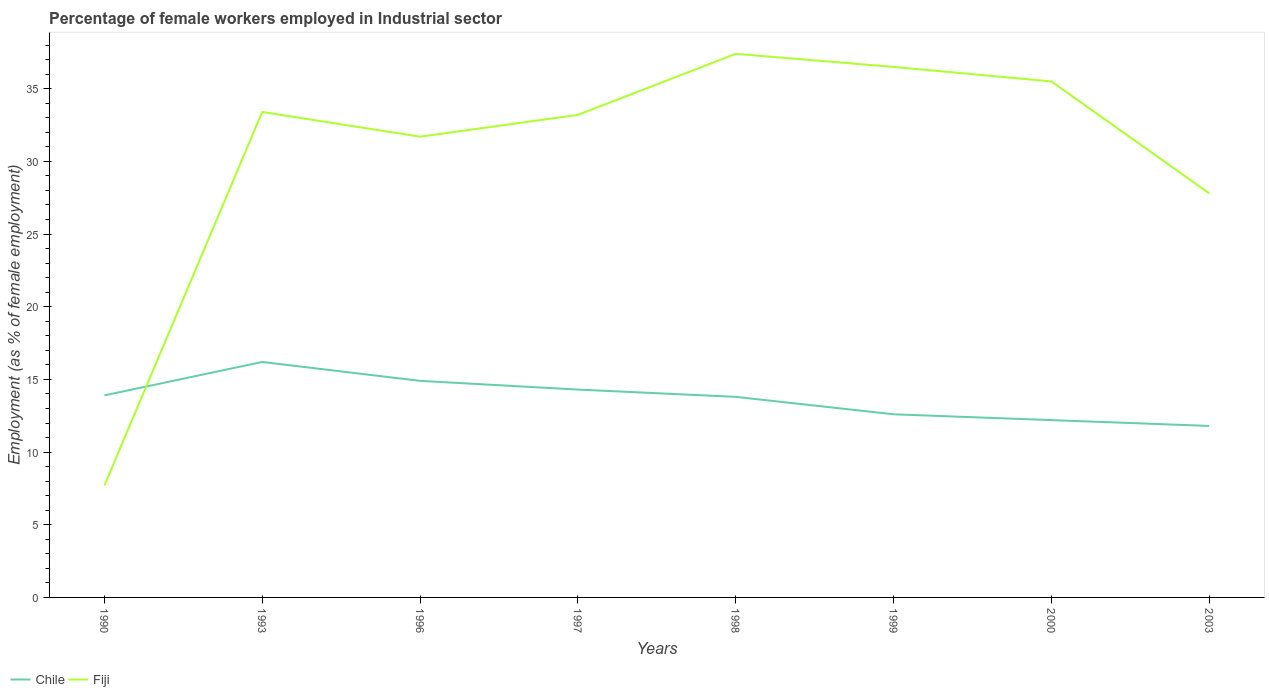How many different coloured lines are there?
Your answer should be compact. 2. Does the line corresponding to Fiji intersect with the line corresponding to Chile?
Your answer should be very brief. Yes. Is the number of lines equal to the number of legend labels?
Your answer should be very brief. Yes. Across all years, what is the maximum percentage of females employed in Industrial sector in Chile?
Provide a short and direct response. 11.8. What is the difference between the highest and the second highest percentage of females employed in Industrial sector in Fiji?
Give a very brief answer. 29.7. How many lines are there?
Offer a terse response. 2. Are the values on the major ticks of Y-axis written in scientific E-notation?
Keep it short and to the point. No. Where does the legend appear in the graph?
Your answer should be very brief. Bottom left. How many legend labels are there?
Offer a terse response. 2. How are the legend labels stacked?
Provide a short and direct response. Horizontal. What is the title of the graph?
Your answer should be very brief. Percentage of female workers employed in Industrial sector. What is the label or title of the X-axis?
Provide a short and direct response. Years. What is the label or title of the Y-axis?
Keep it short and to the point. Employment (as % of female employment). What is the Employment (as % of female employment) in Chile in 1990?
Provide a short and direct response. 13.9. What is the Employment (as % of female employment) in Fiji in 1990?
Give a very brief answer. 7.7. What is the Employment (as % of female employment) of Chile in 1993?
Keep it short and to the point. 16.2. What is the Employment (as % of female employment) in Fiji in 1993?
Make the answer very short. 33.4. What is the Employment (as % of female employment) of Chile in 1996?
Offer a very short reply. 14.9. What is the Employment (as % of female employment) of Fiji in 1996?
Your answer should be compact. 31.7. What is the Employment (as % of female employment) in Chile in 1997?
Your answer should be very brief. 14.3. What is the Employment (as % of female employment) of Fiji in 1997?
Ensure brevity in your answer.  33.2. What is the Employment (as % of female employment) in Chile in 1998?
Your answer should be very brief. 13.8. What is the Employment (as % of female employment) of Fiji in 1998?
Provide a succinct answer. 37.4. What is the Employment (as % of female employment) in Chile in 1999?
Your answer should be very brief. 12.6. What is the Employment (as % of female employment) of Fiji in 1999?
Provide a short and direct response. 36.5. What is the Employment (as % of female employment) in Chile in 2000?
Make the answer very short. 12.2. What is the Employment (as % of female employment) of Fiji in 2000?
Provide a short and direct response. 35.5. What is the Employment (as % of female employment) in Chile in 2003?
Make the answer very short. 11.8. What is the Employment (as % of female employment) in Fiji in 2003?
Offer a very short reply. 27.8. Across all years, what is the maximum Employment (as % of female employment) in Chile?
Your answer should be compact. 16.2. Across all years, what is the maximum Employment (as % of female employment) of Fiji?
Provide a succinct answer. 37.4. Across all years, what is the minimum Employment (as % of female employment) in Chile?
Provide a succinct answer. 11.8. Across all years, what is the minimum Employment (as % of female employment) in Fiji?
Your response must be concise. 7.7. What is the total Employment (as % of female employment) in Chile in the graph?
Make the answer very short. 109.7. What is the total Employment (as % of female employment) in Fiji in the graph?
Your answer should be compact. 243.2. What is the difference between the Employment (as % of female employment) of Fiji in 1990 and that in 1993?
Provide a succinct answer. -25.7. What is the difference between the Employment (as % of female employment) in Chile in 1990 and that in 1996?
Offer a very short reply. -1. What is the difference between the Employment (as % of female employment) of Chile in 1990 and that in 1997?
Provide a short and direct response. -0.4. What is the difference between the Employment (as % of female employment) in Fiji in 1990 and that in 1997?
Offer a very short reply. -25.5. What is the difference between the Employment (as % of female employment) in Fiji in 1990 and that in 1998?
Give a very brief answer. -29.7. What is the difference between the Employment (as % of female employment) of Fiji in 1990 and that in 1999?
Keep it short and to the point. -28.8. What is the difference between the Employment (as % of female employment) in Fiji in 1990 and that in 2000?
Offer a terse response. -27.8. What is the difference between the Employment (as % of female employment) in Chile in 1990 and that in 2003?
Provide a succinct answer. 2.1. What is the difference between the Employment (as % of female employment) in Fiji in 1990 and that in 2003?
Keep it short and to the point. -20.1. What is the difference between the Employment (as % of female employment) of Chile in 1993 and that in 1996?
Your response must be concise. 1.3. What is the difference between the Employment (as % of female employment) of Fiji in 1993 and that in 1996?
Your response must be concise. 1.7. What is the difference between the Employment (as % of female employment) in Chile in 1993 and that in 1998?
Ensure brevity in your answer.  2.4. What is the difference between the Employment (as % of female employment) of Chile in 1993 and that in 1999?
Offer a very short reply. 3.6. What is the difference between the Employment (as % of female employment) of Fiji in 1993 and that in 2000?
Provide a short and direct response. -2.1. What is the difference between the Employment (as % of female employment) of Chile in 1996 and that in 1999?
Offer a terse response. 2.3. What is the difference between the Employment (as % of female employment) of Fiji in 1996 and that in 1999?
Ensure brevity in your answer.  -4.8. What is the difference between the Employment (as % of female employment) of Chile in 1996 and that in 2000?
Provide a succinct answer. 2.7. What is the difference between the Employment (as % of female employment) of Fiji in 1996 and that in 2000?
Your answer should be very brief. -3.8. What is the difference between the Employment (as % of female employment) of Fiji in 1996 and that in 2003?
Your answer should be very brief. 3.9. What is the difference between the Employment (as % of female employment) in Fiji in 1997 and that in 1998?
Your answer should be compact. -4.2. What is the difference between the Employment (as % of female employment) of Chile in 1997 and that in 1999?
Provide a short and direct response. 1.7. What is the difference between the Employment (as % of female employment) in Fiji in 1997 and that in 1999?
Your answer should be compact. -3.3. What is the difference between the Employment (as % of female employment) in Chile in 1997 and that in 2000?
Offer a very short reply. 2.1. What is the difference between the Employment (as % of female employment) in Chile in 1997 and that in 2003?
Your answer should be very brief. 2.5. What is the difference between the Employment (as % of female employment) of Fiji in 1997 and that in 2003?
Provide a short and direct response. 5.4. What is the difference between the Employment (as % of female employment) in Fiji in 1998 and that in 2000?
Provide a succinct answer. 1.9. What is the difference between the Employment (as % of female employment) of Chile in 2000 and that in 2003?
Make the answer very short. 0.4. What is the difference between the Employment (as % of female employment) in Chile in 1990 and the Employment (as % of female employment) in Fiji in 1993?
Provide a short and direct response. -19.5. What is the difference between the Employment (as % of female employment) in Chile in 1990 and the Employment (as % of female employment) in Fiji in 1996?
Give a very brief answer. -17.8. What is the difference between the Employment (as % of female employment) of Chile in 1990 and the Employment (as % of female employment) of Fiji in 1997?
Your response must be concise. -19.3. What is the difference between the Employment (as % of female employment) in Chile in 1990 and the Employment (as % of female employment) in Fiji in 1998?
Your answer should be compact. -23.5. What is the difference between the Employment (as % of female employment) in Chile in 1990 and the Employment (as % of female employment) in Fiji in 1999?
Make the answer very short. -22.6. What is the difference between the Employment (as % of female employment) in Chile in 1990 and the Employment (as % of female employment) in Fiji in 2000?
Offer a very short reply. -21.6. What is the difference between the Employment (as % of female employment) in Chile in 1990 and the Employment (as % of female employment) in Fiji in 2003?
Make the answer very short. -13.9. What is the difference between the Employment (as % of female employment) of Chile in 1993 and the Employment (as % of female employment) of Fiji in 1996?
Keep it short and to the point. -15.5. What is the difference between the Employment (as % of female employment) in Chile in 1993 and the Employment (as % of female employment) in Fiji in 1998?
Provide a succinct answer. -21.2. What is the difference between the Employment (as % of female employment) in Chile in 1993 and the Employment (as % of female employment) in Fiji in 1999?
Offer a terse response. -20.3. What is the difference between the Employment (as % of female employment) of Chile in 1993 and the Employment (as % of female employment) of Fiji in 2000?
Your response must be concise. -19.3. What is the difference between the Employment (as % of female employment) in Chile in 1996 and the Employment (as % of female employment) in Fiji in 1997?
Your answer should be very brief. -18.3. What is the difference between the Employment (as % of female employment) in Chile in 1996 and the Employment (as % of female employment) in Fiji in 1998?
Your response must be concise. -22.5. What is the difference between the Employment (as % of female employment) in Chile in 1996 and the Employment (as % of female employment) in Fiji in 1999?
Provide a short and direct response. -21.6. What is the difference between the Employment (as % of female employment) of Chile in 1996 and the Employment (as % of female employment) of Fiji in 2000?
Provide a succinct answer. -20.6. What is the difference between the Employment (as % of female employment) of Chile in 1997 and the Employment (as % of female employment) of Fiji in 1998?
Keep it short and to the point. -23.1. What is the difference between the Employment (as % of female employment) of Chile in 1997 and the Employment (as % of female employment) of Fiji in 1999?
Offer a very short reply. -22.2. What is the difference between the Employment (as % of female employment) in Chile in 1997 and the Employment (as % of female employment) in Fiji in 2000?
Offer a terse response. -21.2. What is the difference between the Employment (as % of female employment) in Chile in 1998 and the Employment (as % of female employment) in Fiji in 1999?
Provide a succinct answer. -22.7. What is the difference between the Employment (as % of female employment) of Chile in 1998 and the Employment (as % of female employment) of Fiji in 2000?
Keep it short and to the point. -21.7. What is the difference between the Employment (as % of female employment) in Chile in 1999 and the Employment (as % of female employment) in Fiji in 2000?
Offer a very short reply. -22.9. What is the difference between the Employment (as % of female employment) in Chile in 1999 and the Employment (as % of female employment) in Fiji in 2003?
Give a very brief answer. -15.2. What is the difference between the Employment (as % of female employment) in Chile in 2000 and the Employment (as % of female employment) in Fiji in 2003?
Your answer should be very brief. -15.6. What is the average Employment (as % of female employment) of Chile per year?
Provide a succinct answer. 13.71. What is the average Employment (as % of female employment) in Fiji per year?
Provide a succinct answer. 30.4. In the year 1993, what is the difference between the Employment (as % of female employment) of Chile and Employment (as % of female employment) of Fiji?
Provide a short and direct response. -17.2. In the year 1996, what is the difference between the Employment (as % of female employment) of Chile and Employment (as % of female employment) of Fiji?
Provide a short and direct response. -16.8. In the year 1997, what is the difference between the Employment (as % of female employment) of Chile and Employment (as % of female employment) of Fiji?
Give a very brief answer. -18.9. In the year 1998, what is the difference between the Employment (as % of female employment) in Chile and Employment (as % of female employment) in Fiji?
Give a very brief answer. -23.6. In the year 1999, what is the difference between the Employment (as % of female employment) in Chile and Employment (as % of female employment) in Fiji?
Provide a short and direct response. -23.9. In the year 2000, what is the difference between the Employment (as % of female employment) in Chile and Employment (as % of female employment) in Fiji?
Ensure brevity in your answer.  -23.3. In the year 2003, what is the difference between the Employment (as % of female employment) of Chile and Employment (as % of female employment) of Fiji?
Your response must be concise. -16. What is the ratio of the Employment (as % of female employment) in Chile in 1990 to that in 1993?
Offer a very short reply. 0.86. What is the ratio of the Employment (as % of female employment) in Fiji in 1990 to that in 1993?
Make the answer very short. 0.23. What is the ratio of the Employment (as % of female employment) of Chile in 1990 to that in 1996?
Keep it short and to the point. 0.93. What is the ratio of the Employment (as % of female employment) of Fiji in 1990 to that in 1996?
Offer a terse response. 0.24. What is the ratio of the Employment (as % of female employment) of Chile in 1990 to that in 1997?
Offer a very short reply. 0.97. What is the ratio of the Employment (as % of female employment) of Fiji in 1990 to that in 1997?
Keep it short and to the point. 0.23. What is the ratio of the Employment (as % of female employment) of Fiji in 1990 to that in 1998?
Offer a terse response. 0.21. What is the ratio of the Employment (as % of female employment) in Chile in 1990 to that in 1999?
Offer a very short reply. 1.1. What is the ratio of the Employment (as % of female employment) of Fiji in 1990 to that in 1999?
Provide a short and direct response. 0.21. What is the ratio of the Employment (as % of female employment) of Chile in 1990 to that in 2000?
Give a very brief answer. 1.14. What is the ratio of the Employment (as % of female employment) of Fiji in 1990 to that in 2000?
Your answer should be very brief. 0.22. What is the ratio of the Employment (as % of female employment) of Chile in 1990 to that in 2003?
Make the answer very short. 1.18. What is the ratio of the Employment (as % of female employment) of Fiji in 1990 to that in 2003?
Your response must be concise. 0.28. What is the ratio of the Employment (as % of female employment) in Chile in 1993 to that in 1996?
Offer a terse response. 1.09. What is the ratio of the Employment (as % of female employment) in Fiji in 1993 to that in 1996?
Keep it short and to the point. 1.05. What is the ratio of the Employment (as % of female employment) in Chile in 1993 to that in 1997?
Provide a short and direct response. 1.13. What is the ratio of the Employment (as % of female employment) of Chile in 1993 to that in 1998?
Keep it short and to the point. 1.17. What is the ratio of the Employment (as % of female employment) of Fiji in 1993 to that in 1998?
Provide a short and direct response. 0.89. What is the ratio of the Employment (as % of female employment) of Fiji in 1993 to that in 1999?
Your answer should be compact. 0.92. What is the ratio of the Employment (as % of female employment) in Chile in 1993 to that in 2000?
Your answer should be compact. 1.33. What is the ratio of the Employment (as % of female employment) in Fiji in 1993 to that in 2000?
Offer a very short reply. 0.94. What is the ratio of the Employment (as % of female employment) of Chile in 1993 to that in 2003?
Ensure brevity in your answer.  1.37. What is the ratio of the Employment (as % of female employment) in Fiji in 1993 to that in 2003?
Give a very brief answer. 1.2. What is the ratio of the Employment (as % of female employment) of Chile in 1996 to that in 1997?
Ensure brevity in your answer.  1.04. What is the ratio of the Employment (as % of female employment) of Fiji in 1996 to that in 1997?
Your answer should be very brief. 0.95. What is the ratio of the Employment (as % of female employment) in Chile in 1996 to that in 1998?
Offer a very short reply. 1.08. What is the ratio of the Employment (as % of female employment) of Fiji in 1996 to that in 1998?
Make the answer very short. 0.85. What is the ratio of the Employment (as % of female employment) in Chile in 1996 to that in 1999?
Provide a short and direct response. 1.18. What is the ratio of the Employment (as % of female employment) of Fiji in 1996 to that in 1999?
Keep it short and to the point. 0.87. What is the ratio of the Employment (as % of female employment) of Chile in 1996 to that in 2000?
Give a very brief answer. 1.22. What is the ratio of the Employment (as % of female employment) in Fiji in 1996 to that in 2000?
Make the answer very short. 0.89. What is the ratio of the Employment (as % of female employment) in Chile in 1996 to that in 2003?
Your response must be concise. 1.26. What is the ratio of the Employment (as % of female employment) in Fiji in 1996 to that in 2003?
Ensure brevity in your answer.  1.14. What is the ratio of the Employment (as % of female employment) of Chile in 1997 to that in 1998?
Give a very brief answer. 1.04. What is the ratio of the Employment (as % of female employment) of Fiji in 1997 to that in 1998?
Offer a terse response. 0.89. What is the ratio of the Employment (as % of female employment) in Chile in 1997 to that in 1999?
Provide a short and direct response. 1.13. What is the ratio of the Employment (as % of female employment) of Fiji in 1997 to that in 1999?
Keep it short and to the point. 0.91. What is the ratio of the Employment (as % of female employment) in Chile in 1997 to that in 2000?
Offer a very short reply. 1.17. What is the ratio of the Employment (as % of female employment) in Fiji in 1997 to that in 2000?
Keep it short and to the point. 0.94. What is the ratio of the Employment (as % of female employment) of Chile in 1997 to that in 2003?
Provide a succinct answer. 1.21. What is the ratio of the Employment (as % of female employment) in Fiji in 1997 to that in 2003?
Offer a terse response. 1.19. What is the ratio of the Employment (as % of female employment) in Chile in 1998 to that in 1999?
Ensure brevity in your answer.  1.1. What is the ratio of the Employment (as % of female employment) in Fiji in 1998 to that in 1999?
Offer a terse response. 1.02. What is the ratio of the Employment (as % of female employment) of Chile in 1998 to that in 2000?
Make the answer very short. 1.13. What is the ratio of the Employment (as % of female employment) in Fiji in 1998 to that in 2000?
Make the answer very short. 1.05. What is the ratio of the Employment (as % of female employment) of Chile in 1998 to that in 2003?
Your answer should be very brief. 1.17. What is the ratio of the Employment (as % of female employment) of Fiji in 1998 to that in 2003?
Your answer should be very brief. 1.35. What is the ratio of the Employment (as % of female employment) of Chile in 1999 to that in 2000?
Your answer should be very brief. 1.03. What is the ratio of the Employment (as % of female employment) of Fiji in 1999 to that in 2000?
Provide a succinct answer. 1.03. What is the ratio of the Employment (as % of female employment) in Chile in 1999 to that in 2003?
Ensure brevity in your answer.  1.07. What is the ratio of the Employment (as % of female employment) of Fiji in 1999 to that in 2003?
Your answer should be compact. 1.31. What is the ratio of the Employment (as % of female employment) of Chile in 2000 to that in 2003?
Ensure brevity in your answer.  1.03. What is the ratio of the Employment (as % of female employment) in Fiji in 2000 to that in 2003?
Your answer should be very brief. 1.28. What is the difference between the highest and the second highest Employment (as % of female employment) in Chile?
Give a very brief answer. 1.3. What is the difference between the highest and the second highest Employment (as % of female employment) of Fiji?
Offer a terse response. 0.9. What is the difference between the highest and the lowest Employment (as % of female employment) in Chile?
Keep it short and to the point. 4.4. What is the difference between the highest and the lowest Employment (as % of female employment) in Fiji?
Your answer should be very brief. 29.7. 